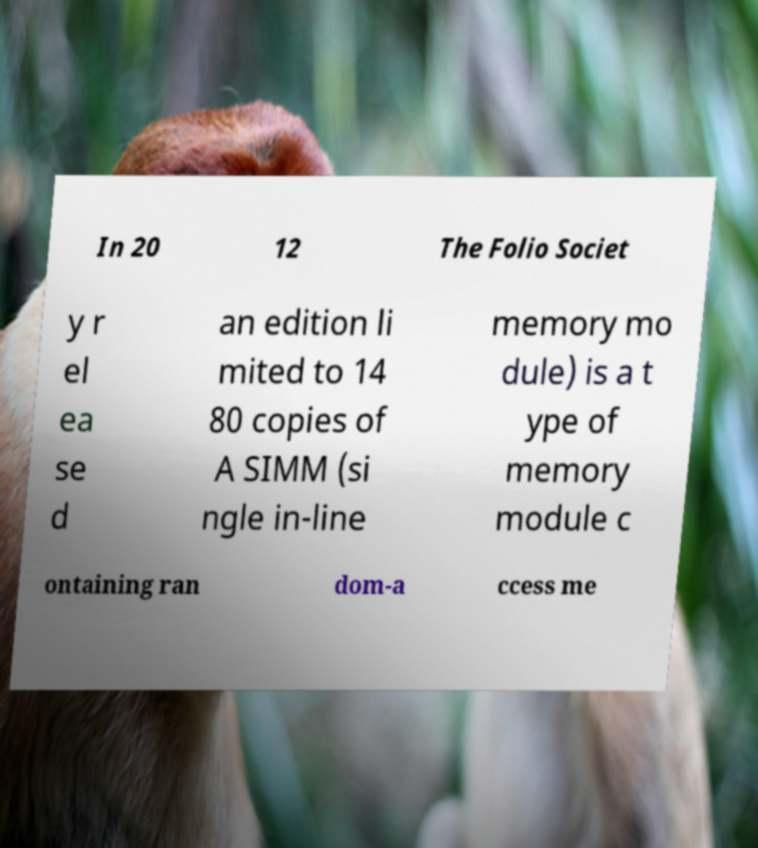What messages or text are displayed in this image? I need them in a readable, typed format. In 20 12 The Folio Societ y r el ea se d an edition li mited to 14 80 copies of A SIMM (si ngle in-line memory mo dule) is a t ype of memory module c ontaining ran dom-a ccess me 